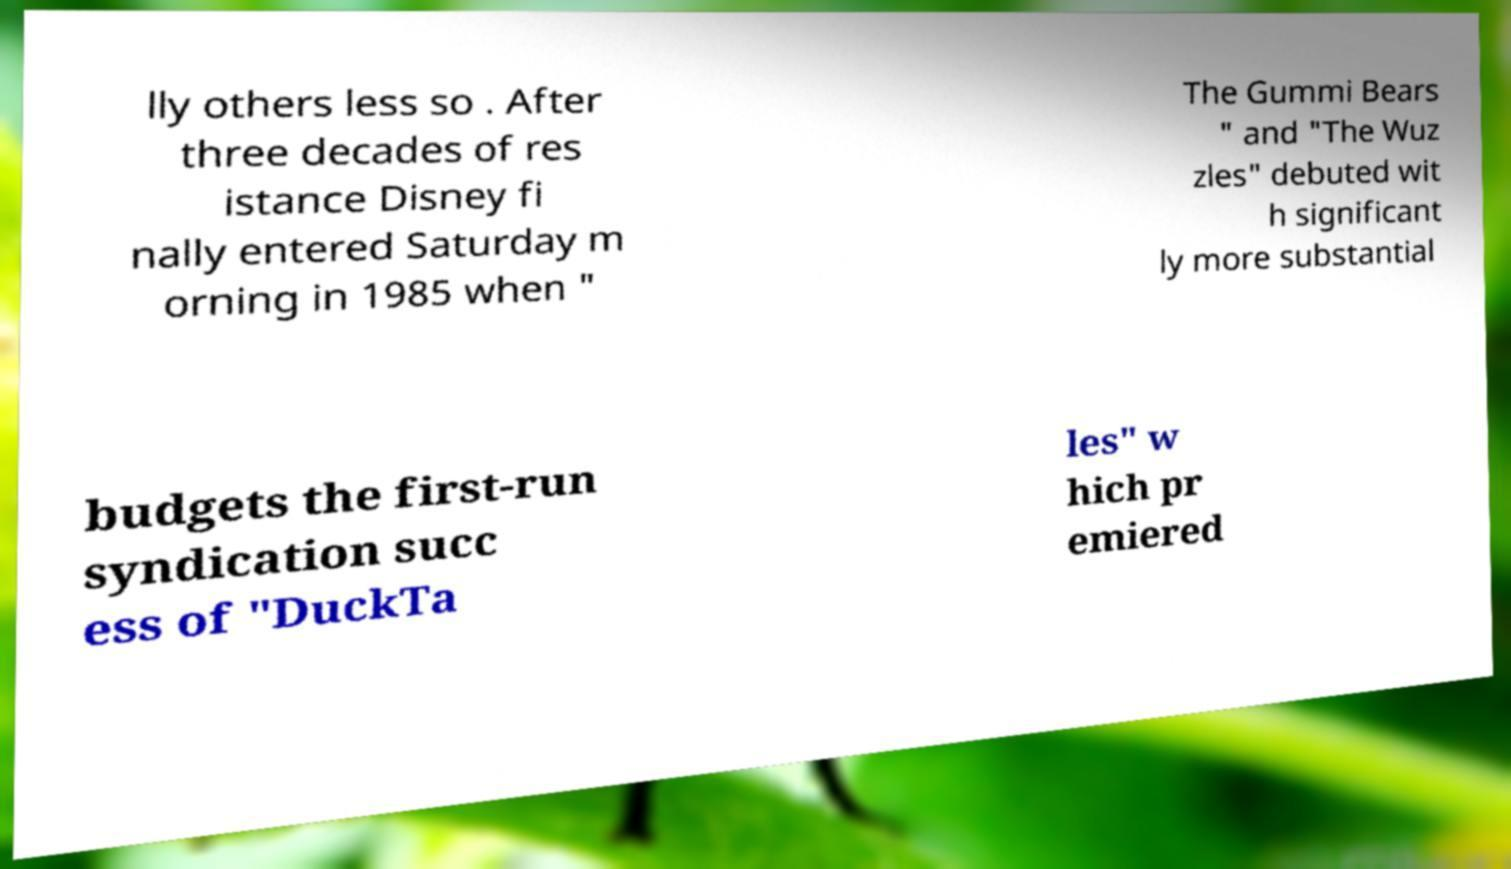Please identify and transcribe the text found in this image. lly others less so . After three decades of res istance Disney fi nally entered Saturday m orning in 1985 when " The Gummi Bears " and "The Wuz zles" debuted wit h significant ly more substantial budgets the first-run syndication succ ess of "DuckTa les" w hich pr emiered 